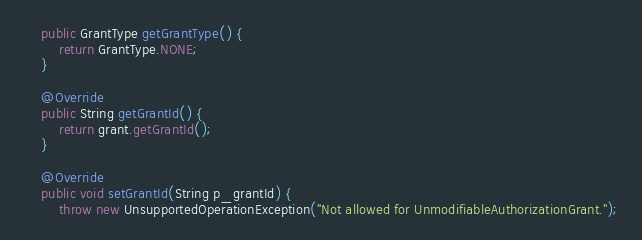Convert code to text. <code><loc_0><loc_0><loc_500><loc_500><_Java_>    public GrantType getGrantType() {
        return GrantType.NONE;
    }

    @Override
    public String getGrantId() {
        return grant.getGrantId();
    }

    @Override
    public void setGrantId(String p_grantId) {
        throw new UnsupportedOperationException("Not allowed for UnmodifiableAuthorizationGrant.");</code> 